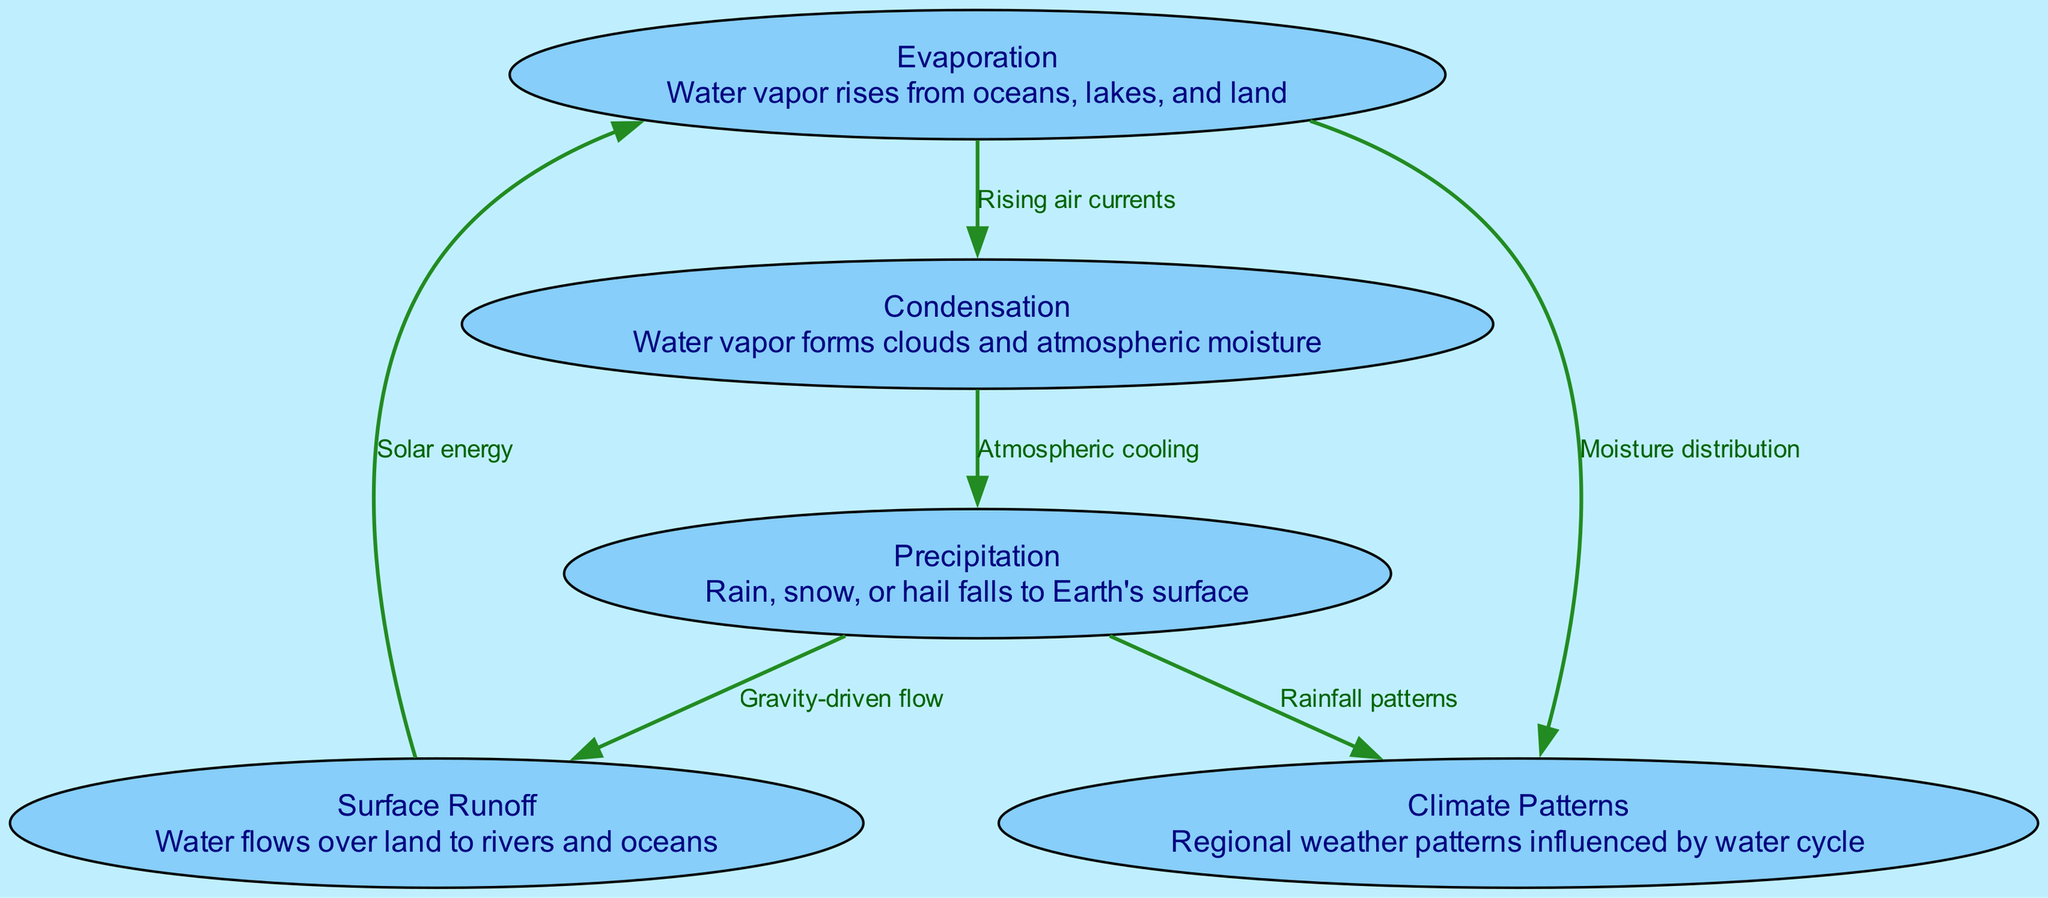What are the main stages of the water cycle shown in the diagram? The diagram identifies five key stages: Evaporation, Condensation, Precipitation, Surface Runoff, and Climate Patterns, each represented as a node.
Answer: Evaporation, Condensation, Precipitation, Surface Runoff, Climate Patterns How many nodes are present in the diagram? The diagram consists of five nodes representing different components of the water cycle and climate patterns.
Answer: 5 What is the relationship labeled between evaporation and condensation? The edge between evaporation and condensation is labeled "Rising air currents," indicating the process through which water vapor rises and cools to form clouds.
Answer: Rising air currents Which process is driven by gravity in the water cycle? The edge from precipitation to runoff is labeled "Gravity-driven flow," signifying that the water moves downwards due to gravity.
Answer: Gravity-driven flow What two factors contribute to climate patterns in the water cycle? The diagram shows that evaporation and precipitation influence climate patterns, indicated by edges leading from these nodes to "Climate Patterns."
Answer: Moisture distribution and Rainfall patterns How does precipitation affect climate patterns? The diagram illustrates that precipitation impacts climate patterns through established rainfall patterns, represented as a direct connection in the diagram.
Answer: Rainfall patterns Which node is the starting point for the water cycle as shown in the diagram? The edges indicate that evaporation is the starting point, as it initiates the cycle by converting water into vapor.
Answer: Evaporation What type of edge connects condensation to precipitation? The relationship between condensation and precipitation is represented by an edge labeled "Atmospheric cooling," describing the cooling process that leads to precipitation.
Answer: Atmospheric cooling How does surface runoff relate to evaporation? The diagram shows that surface runoff leads back to evaporation, facilitated by solar energy, indicating a cyclical relationship between these two processes.
Answer: Solar energy 